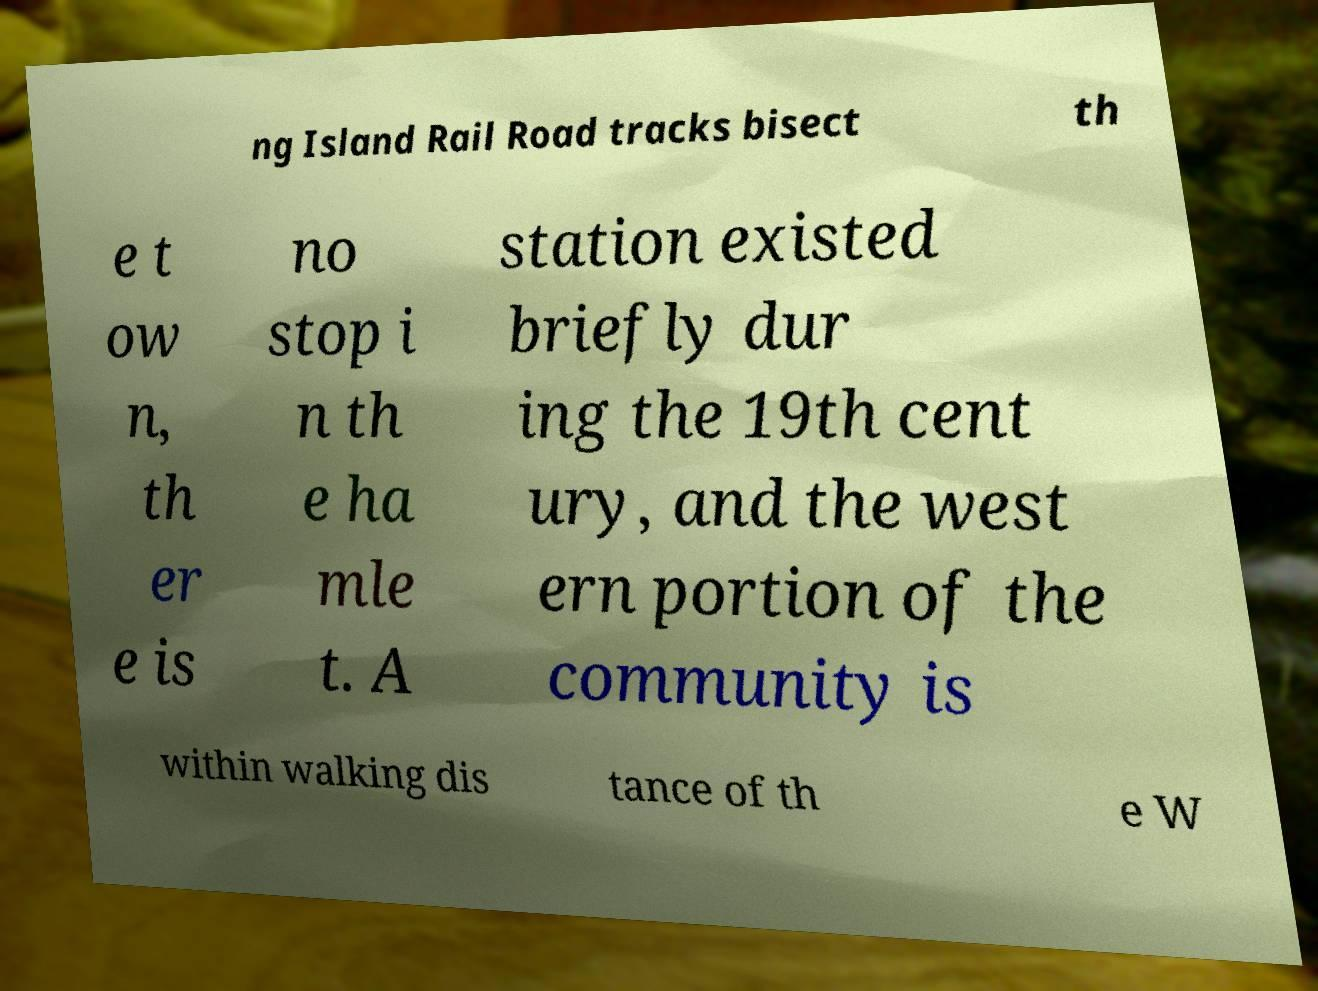Could you assist in decoding the text presented in this image and type it out clearly? ng Island Rail Road tracks bisect th e t ow n, th er e is no stop i n th e ha mle t. A station existed briefly dur ing the 19th cent ury, and the west ern portion of the community is within walking dis tance of th e W 